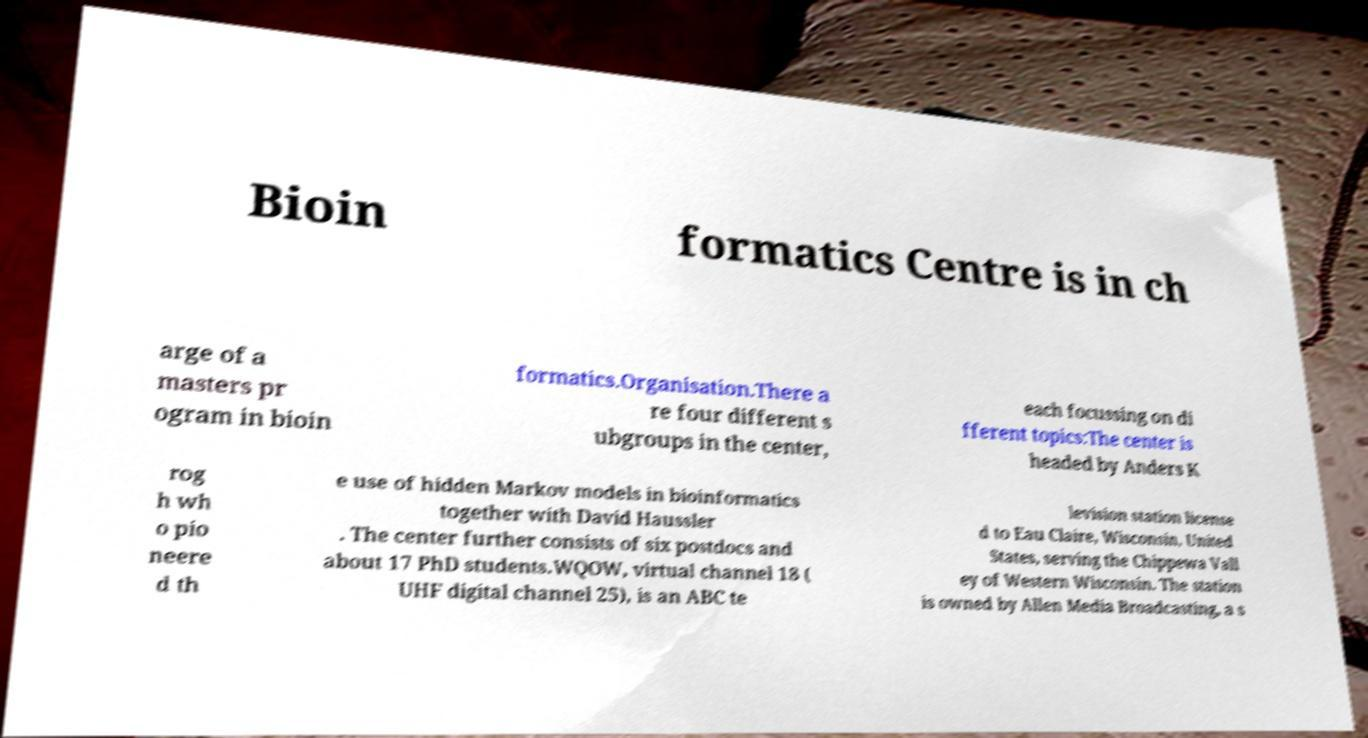Can you read and provide the text displayed in the image?This photo seems to have some interesting text. Can you extract and type it out for me? Bioin formatics Centre is in ch arge of a masters pr ogram in bioin formatics.Organisation.There a re four different s ubgroups in the center, each focussing on di fferent topics:The center is headed by Anders K rog h wh o pio neere d th e use of hidden Markov models in bioinformatics together with David Haussler . The center further consists of six postdocs and about 17 PhD students.WQOW, virtual channel 18 ( UHF digital channel 25), is an ABC te levision station license d to Eau Claire, Wisconsin, United States, serving the Chippewa Vall ey of Western Wisconsin. The station is owned by Allen Media Broadcasting, a s 